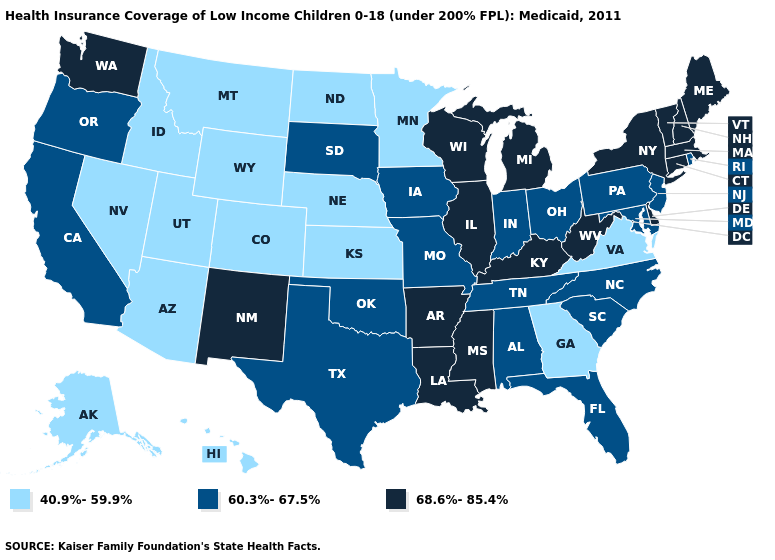What is the value of Wisconsin?
Concise answer only. 68.6%-85.4%. Does Maine have the same value as New York?
Quick response, please. Yes. Does North Dakota have the lowest value in the USA?
Keep it brief. Yes. What is the highest value in the MidWest ?
Short answer required. 68.6%-85.4%. What is the value of Delaware?
Quick response, please. 68.6%-85.4%. Name the states that have a value in the range 68.6%-85.4%?
Short answer required. Arkansas, Connecticut, Delaware, Illinois, Kentucky, Louisiana, Maine, Massachusetts, Michigan, Mississippi, New Hampshire, New Mexico, New York, Vermont, Washington, West Virginia, Wisconsin. Among the states that border New Mexico , which have the highest value?
Be succinct. Oklahoma, Texas. Name the states that have a value in the range 40.9%-59.9%?
Give a very brief answer. Alaska, Arizona, Colorado, Georgia, Hawaii, Idaho, Kansas, Minnesota, Montana, Nebraska, Nevada, North Dakota, Utah, Virginia, Wyoming. Name the states that have a value in the range 60.3%-67.5%?
Short answer required. Alabama, California, Florida, Indiana, Iowa, Maryland, Missouri, New Jersey, North Carolina, Ohio, Oklahoma, Oregon, Pennsylvania, Rhode Island, South Carolina, South Dakota, Tennessee, Texas. Which states have the highest value in the USA?
Answer briefly. Arkansas, Connecticut, Delaware, Illinois, Kentucky, Louisiana, Maine, Massachusetts, Michigan, Mississippi, New Hampshire, New Mexico, New York, Vermont, Washington, West Virginia, Wisconsin. What is the value of Oklahoma?
Answer briefly. 60.3%-67.5%. What is the value of Iowa?
Quick response, please. 60.3%-67.5%. Name the states that have a value in the range 68.6%-85.4%?
Give a very brief answer. Arkansas, Connecticut, Delaware, Illinois, Kentucky, Louisiana, Maine, Massachusetts, Michigan, Mississippi, New Hampshire, New Mexico, New York, Vermont, Washington, West Virginia, Wisconsin. Name the states that have a value in the range 60.3%-67.5%?
Concise answer only. Alabama, California, Florida, Indiana, Iowa, Maryland, Missouri, New Jersey, North Carolina, Ohio, Oklahoma, Oregon, Pennsylvania, Rhode Island, South Carolina, South Dakota, Tennessee, Texas. What is the lowest value in the Northeast?
Be succinct. 60.3%-67.5%. 